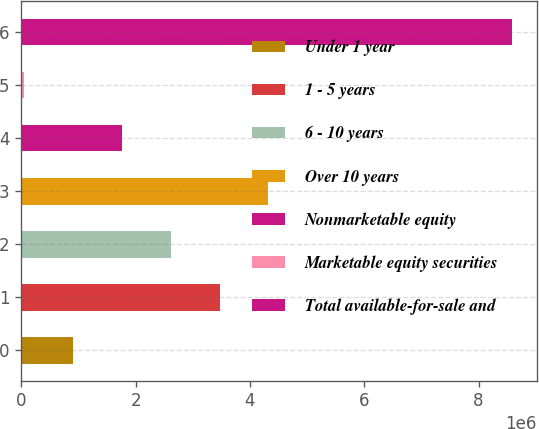Convert chart. <chart><loc_0><loc_0><loc_500><loc_500><bar_chart><fcel>Under 1 year<fcel>1 - 5 years<fcel>6 - 10 years<fcel>Over 10 years<fcel>Nonmarketable equity<fcel>Marketable equity securities<fcel>Total available-for-sale and<nl><fcel>907380<fcel>3.46756e+06<fcel>2.61417e+06<fcel>4.32095e+06<fcel>1.76077e+06<fcel>53987<fcel>8.58791e+06<nl></chart> 